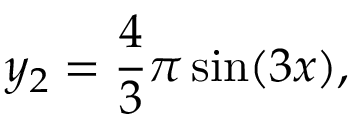<formula> <loc_0><loc_0><loc_500><loc_500>y _ { 2 } = \frac { 4 } { 3 } \pi \sin ( 3 x ) ,</formula> 